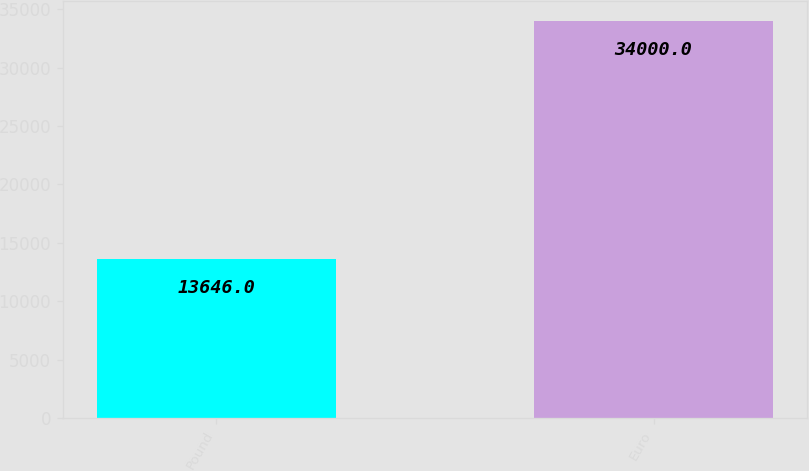Convert chart to OTSL. <chart><loc_0><loc_0><loc_500><loc_500><bar_chart><fcel>Pound<fcel>Euro<nl><fcel>13646<fcel>34000<nl></chart> 